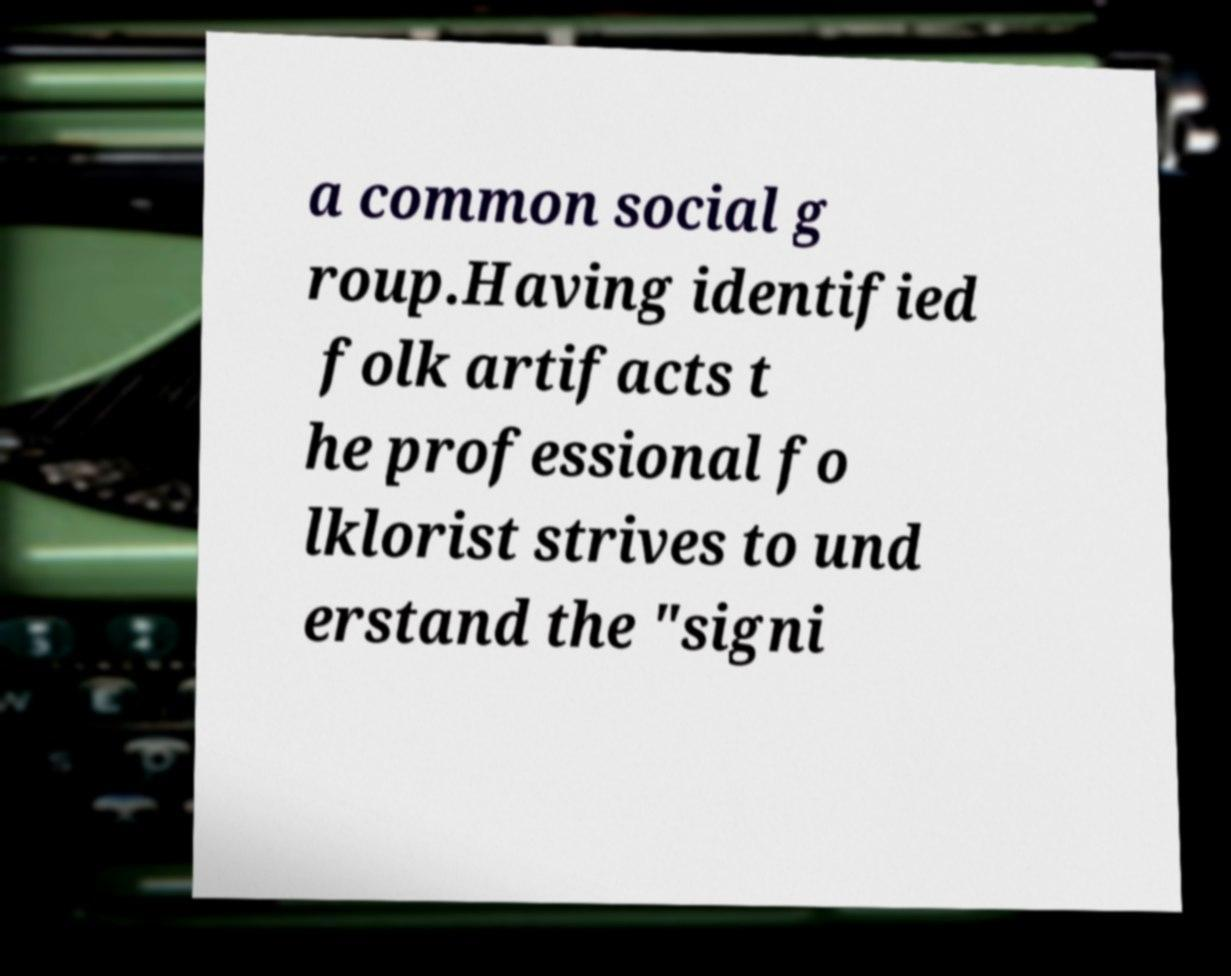Can you read and provide the text displayed in the image?This photo seems to have some interesting text. Can you extract and type it out for me? a common social g roup.Having identified folk artifacts t he professional fo lklorist strives to und erstand the "signi 